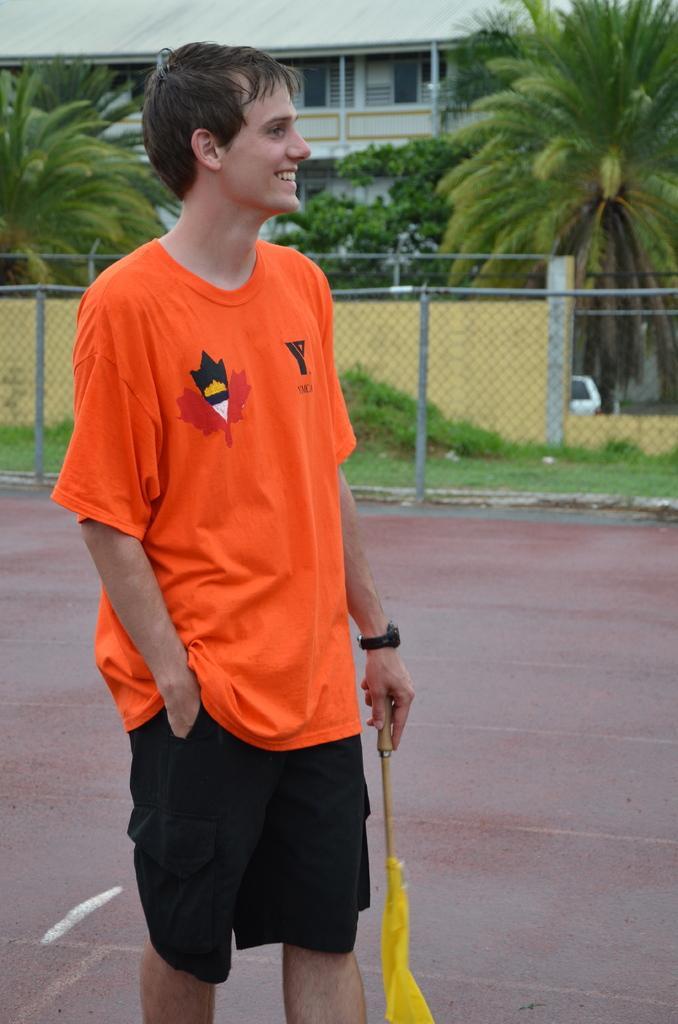Please provide a concise description of this image. In this image we can see a person wearing a T-shirt holding a flag. In the background of the image there is a house, trees, fencing. At the bottom of the image there is floor. 